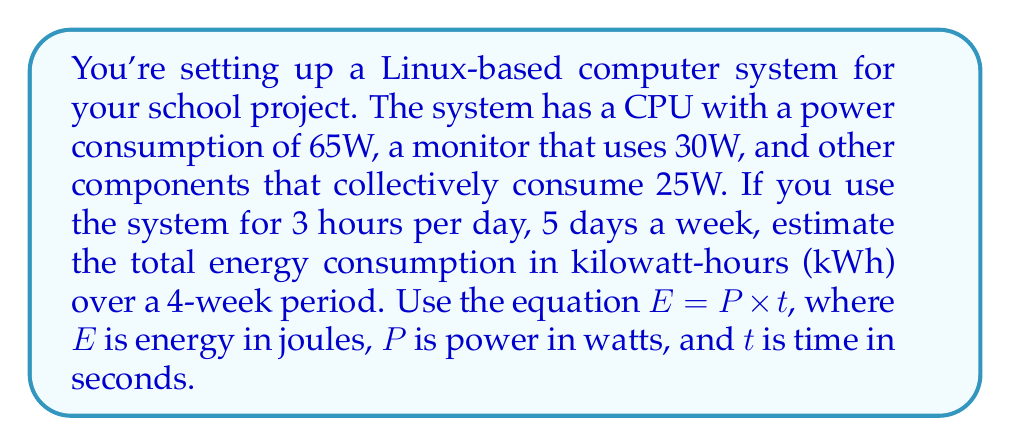Solve this math problem. Let's approach this step-by-step:

1) First, calculate the total power consumption of the system:
   $P_{total} = P_{CPU} + P_{monitor} + P_{other}$
   $P_{total} = 65W + 30W + 25W = 120W$

2) Now, let's calculate the time in seconds:
   3 hours per day, 5 days a week, for 4 weeks
   $t = 3 \times 5 \times 4 \times 3600$ seconds (3600 seconds in an hour)
   $t = 216,000$ seconds

3) Using the equation $E = P \times t$:
   $E = 120W \times 216,000s = 25,920,000 J$

4) Convert joules to kilowatt-hours:
   $1 kWh = 3,600,000 J$
   $E_{kWh} = \frac{25,920,000 J}{3,600,000 J/kWh} = 7.2 kWh$

Therefore, the total energy consumption over the 4-week period is 7.2 kWh.
Answer: 7.2 kWh 